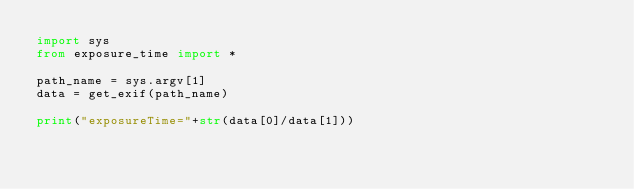<code> <loc_0><loc_0><loc_500><loc_500><_Python_>import sys
from exposure_time import *

path_name = sys.argv[1]
data = get_exif(path_name)

print("exposureTime="+str(data[0]/data[1]))

</code> 